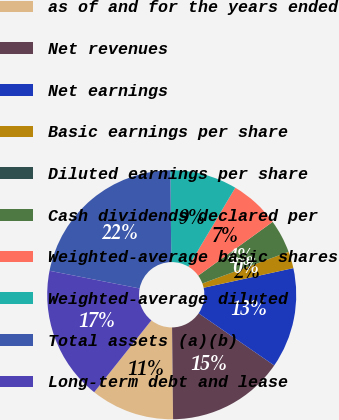Convert chart to OTSL. <chart><loc_0><loc_0><loc_500><loc_500><pie_chart><fcel>as of and for the years ended<fcel>Net revenues<fcel>Net earnings<fcel>Basic earnings per share<fcel>Diluted earnings per share<fcel>Cash dividends declared per<fcel>Weighted-average basic shares<fcel>Weighted-average diluted<fcel>Total assets (a)(b)<fcel>Long-term debt and lease<nl><fcel>10.87%<fcel>15.22%<fcel>13.04%<fcel>2.17%<fcel>0.0%<fcel>4.35%<fcel>6.52%<fcel>8.7%<fcel>21.74%<fcel>17.39%<nl></chart> 